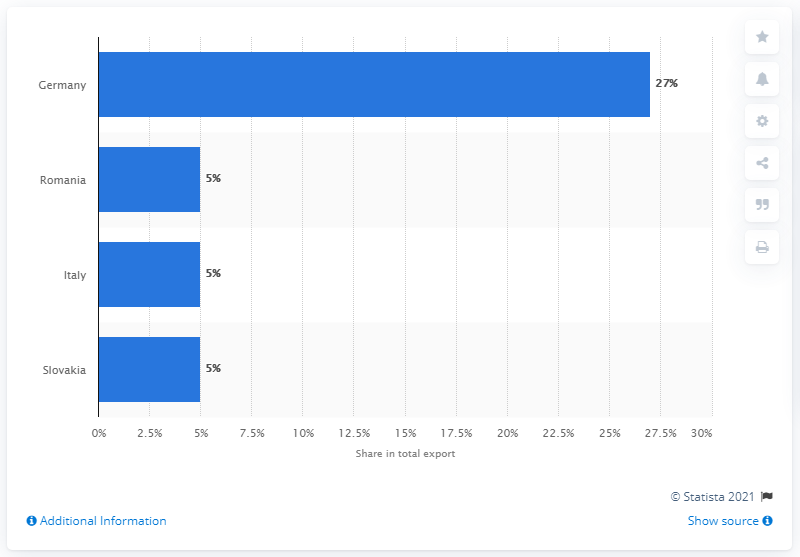Outline some significant characteristics in this image. According to data from 2019, Germany was the most significant export partner for Hungary, accounting for a significant proportion of Hungary's total exports. 